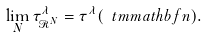<formula> <loc_0><loc_0><loc_500><loc_500>\lim _ { N } \tau ^ { \lambda } _ { \mathcal { R } ^ { N } } = \tau ^ { \lambda } ( \ t m m a t h b f { n } ) .</formula> 